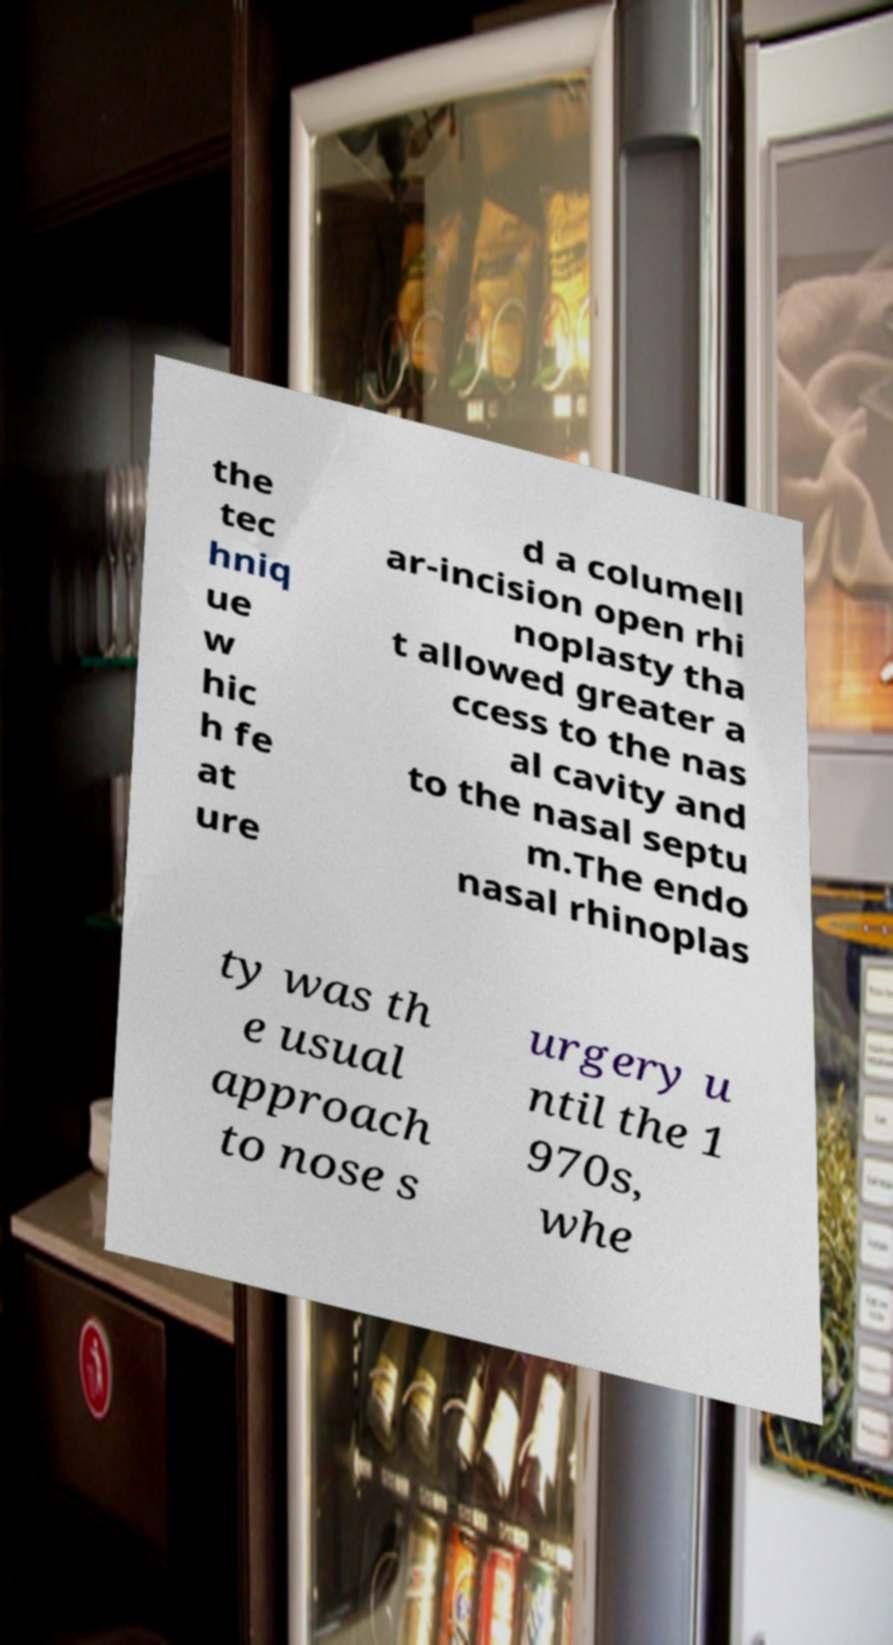Could you assist in decoding the text presented in this image and type it out clearly? the tec hniq ue w hic h fe at ure d a columell ar-incision open rhi noplasty tha t allowed greater a ccess to the nas al cavity and to the nasal septu m.The endo nasal rhinoplas ty was th e usual approach to nose s urgery u ntil the 1 970s, whe 